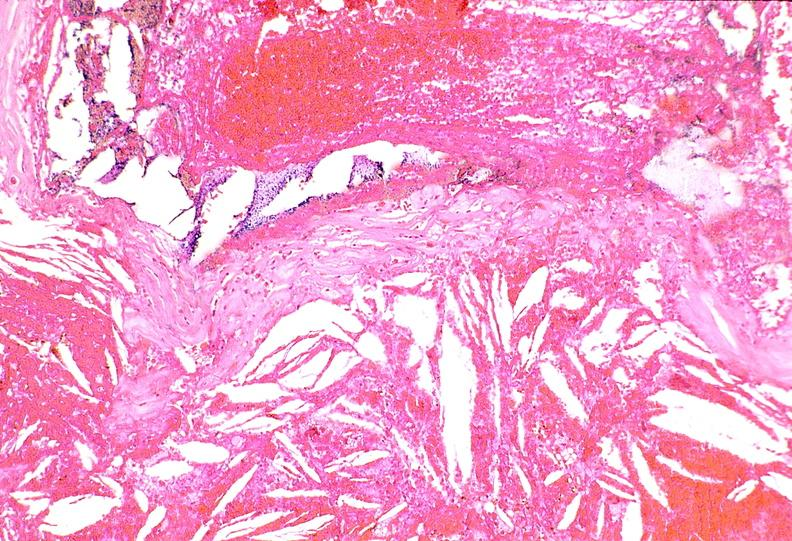s cardiovascular present?
Answer the question using a single word or phrase. Yes 